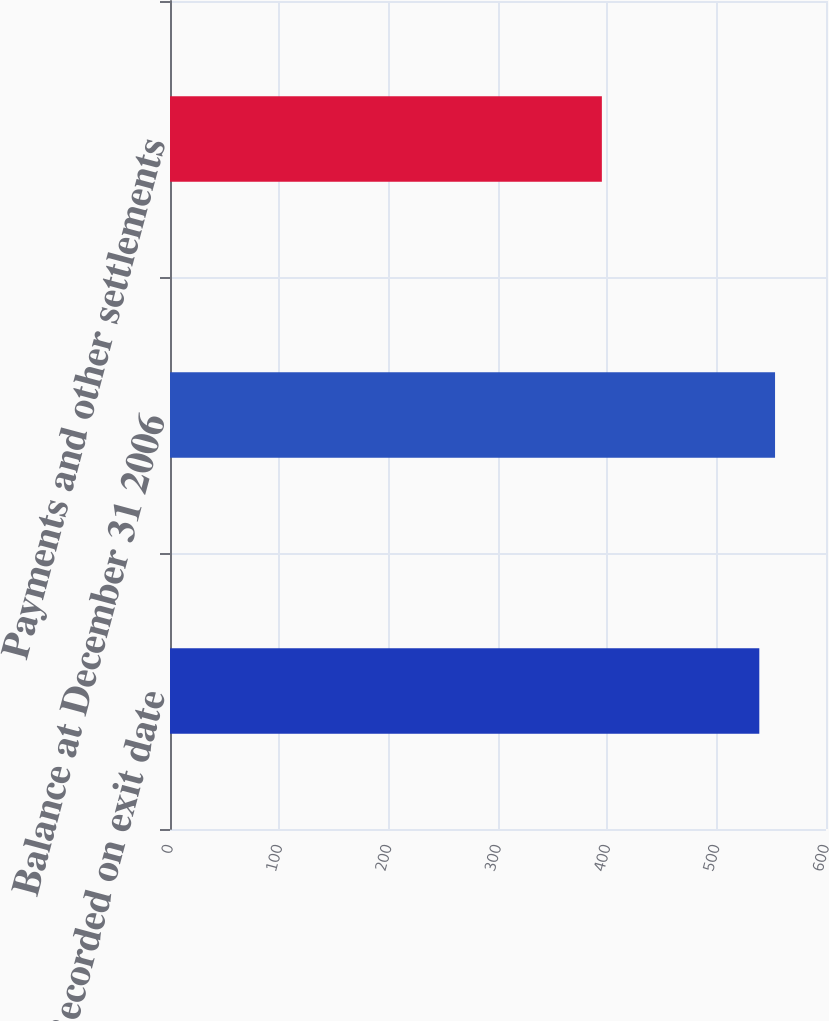<chart> <loc_0><loc_0><loc_500><loc_500><bar_chart><fcel>Recorded on exit date<fcel>Balance at December 31 2006<fcel>Payments and other settlements<nl><fcel>539<fcel>553.4<fcel>395<nl></chart> 